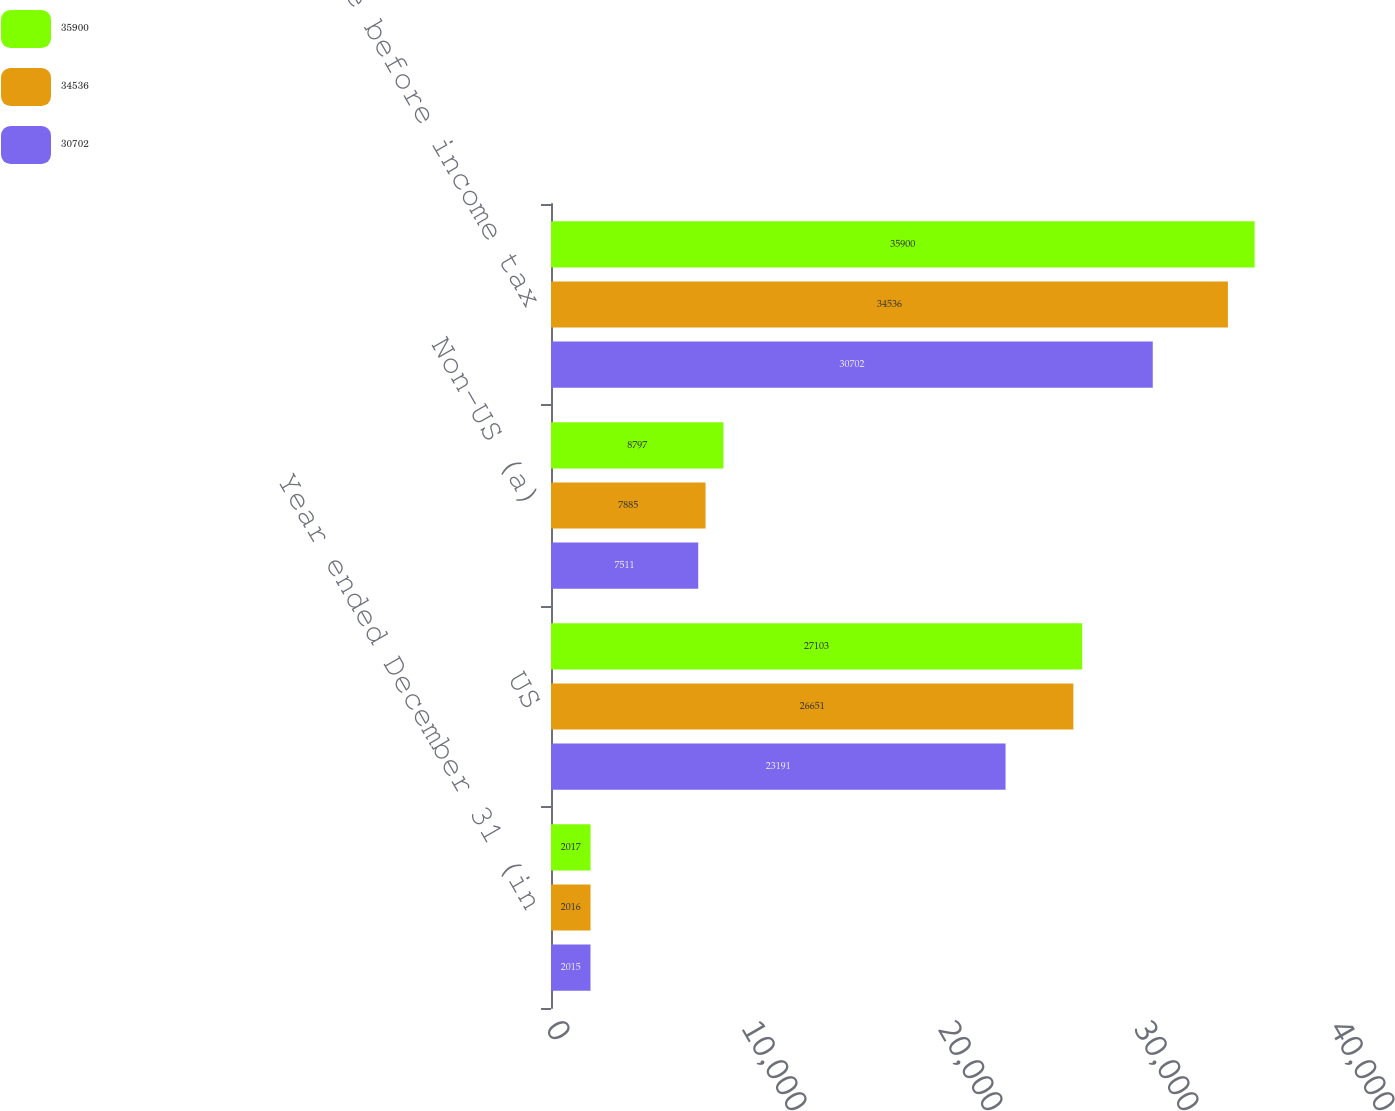Convert chart. <chart><loc_0><loc_0><loc_500><loc_500><stacked_bar_chart><ecel><fcel>Year ended December 31 (in<fcel>US<fcel>Non-US (a)<fcel>Income before income tax<nl><fcel>35900<fcel>2017<fcel>27103<fcel>8797<fcel>35900<nl><fcel>34536<fcel>2016<fcel>26651<fcel>7885<fcel>34536<nl><fcel>30702<fcel>2015<fcel>23191<fcel>7511<fcel>30702<nl></chart> 